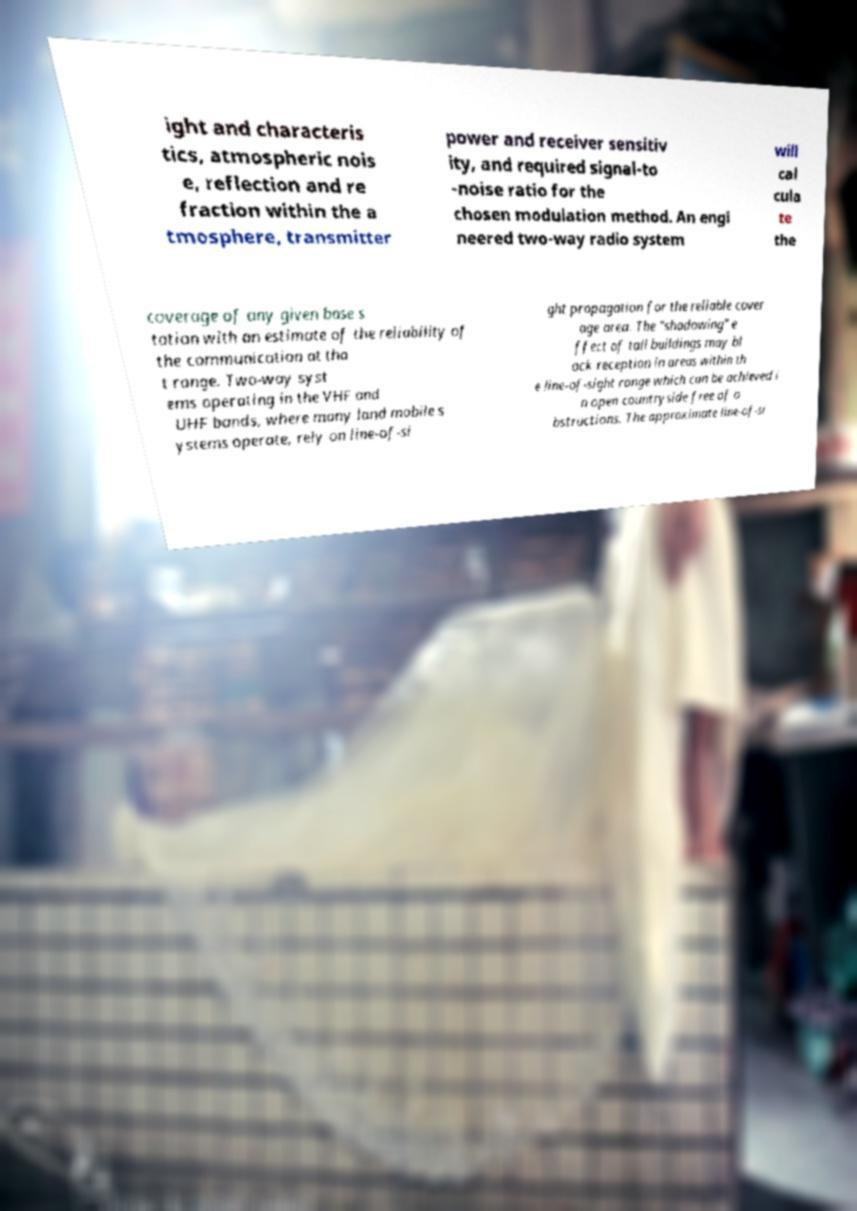There's text embedded in this image that I need extracted. Can you transcribe it verbatim? ight and characteris tics, atmospheric nois e, reflection and re fraction within the a tmosphere, transmitter power and receiver sensitiv ity, and required signal-to -noise ratio for the chosen modulation method. An engi neered two-way radio system will cal cula te the coverage of any given base s tation with an estimate of the reliability of the communication at tha t range. Two-way syst ems operating in the VHF and UHF bands, where many land mobile s ystems operate, rely on line-of-si ght propagation for the reliable cover age area. The "shadowing" e ffect of tall buildings may bl ock reception in areas within th e line-of-sight range which can be achieved i n open countryside free of o bstructions. The approximate line-of-si 